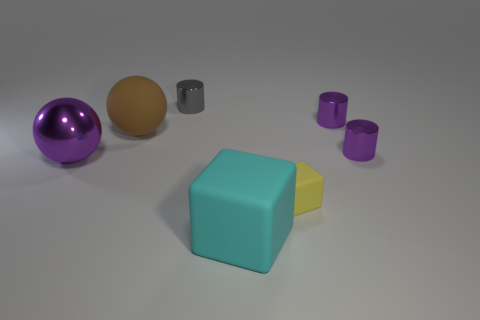Add 1 shiny objects. How many objects exist? 8 Subtract all cubes. How many objects are left? 5 Subtract all large brown rubber cylinders. Subtract all tiny shiny objects. How many objects are left? 4 Add 3 small cubes. How many small cubes are left? 4 Add 5 tiny blue blocks. How many tiny blue blocks exist? 5 Subtract 0 red cubes. How many objects are left? 7 